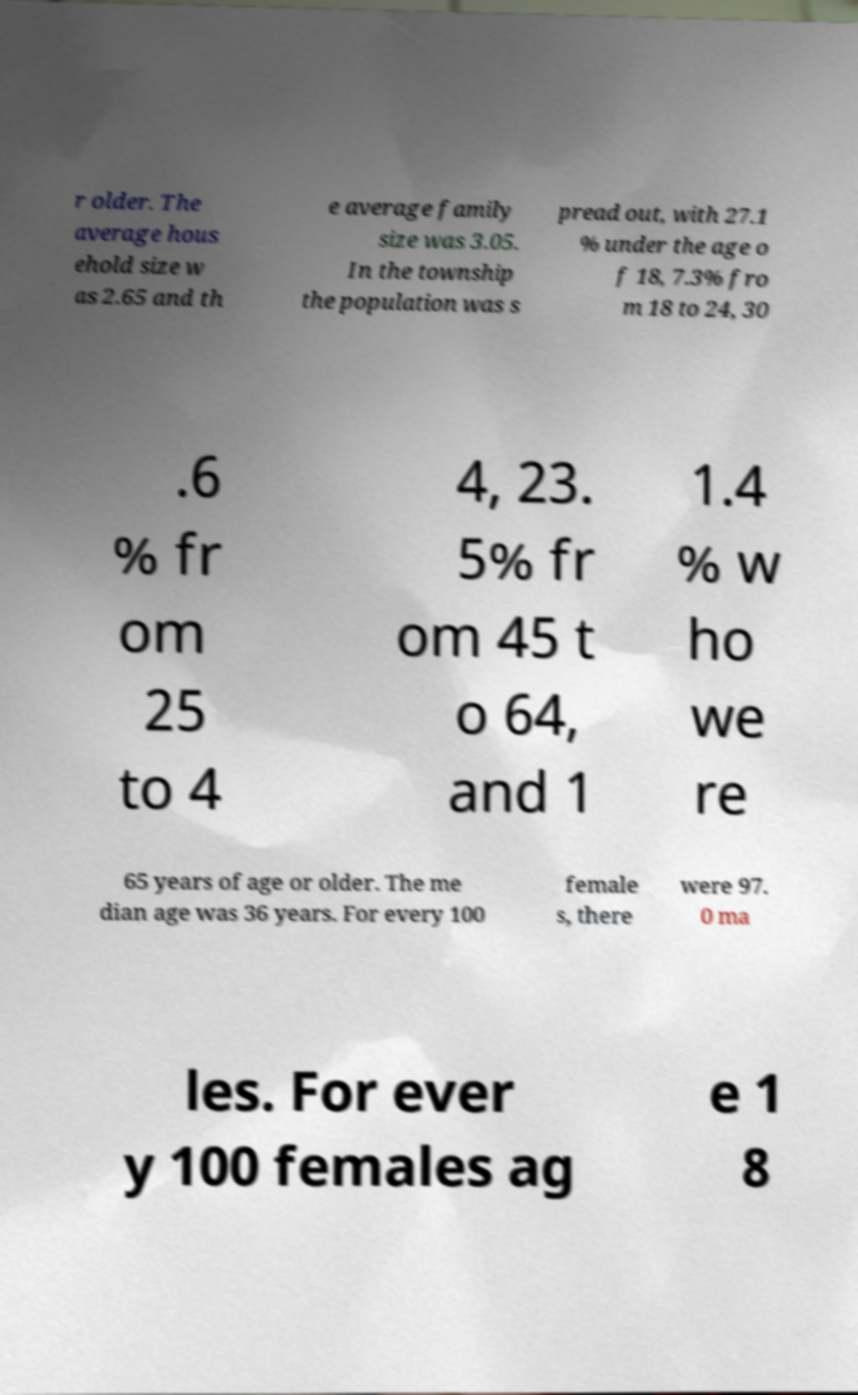Can you accurately transcribe the text from the provided image for me? r older. The average hous ehold size w as 2.65 and th e average family size was 3.05. In the township the population was s pread out, with 27.1 % under the age o f 18, 7.3% fro m 18 to 24, 30 .6 % fr om 25 to 4 4, 23. 5% fr om 45 t o 64, and 1 1.4 % w ho we re 65 years of age or older. The me dian age was 36 years. For every 100 female s, there were 97. 0 ma les. For ever y 100 females ag e 1 8 